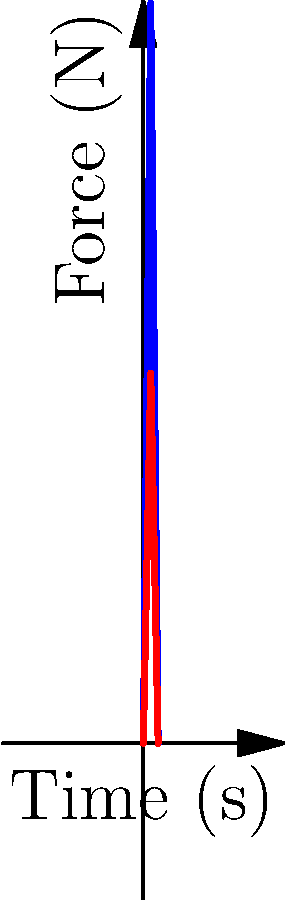The graph shows force-plate data comparing the vertical ground reaction force during a single step for a healthy control and an ankylosing spondylitis (AS) patient. What key biomechanical difference does this data suggest about the AS patient's gait, and how might this inform your therapeutic exercise approach? To analyze this force-plate data and understand its implications for an AS patient's gait, let's break it down step-by-step:

1. Curve interpretation:
   - The blue curve represents the healthy control's vertical ground reaction force.
   - The red curve represents the AS patient's vertical ground reaction force.

2. Key differences:
   - Peak force: The healthy control's peak force is approximately 150N, while the AS patient's peak is about 75N.
   - Force generation rate: The slope of the curve is steeper for the healthy control, indicating a faster rate of force development.

3. Biomechanical implications:
   - Reduced peak force: The AS patient is generating significantly less vertical force during the step, suggesting decreased weight-bearing or force production capacity.
   - Slower force development: The more gradual increase in force for the AS patient may indicate slower weight transfer or difficulty in rapid force production.

4. Potential causes in AS patients:
   - Spinal stiffness and reduced mobility
   - Pain avoidance behaviors
   - Muscle weakness, particularly in the lower extremities
   - Altered proprioception and balance issues

5. Therapeutic exercise approach:
   - Focus on improving lower extremity strength, particularly in weight-bearing positions.
   - Incorporate exercises that challenge rapid force production, such as plyometrics or quick stepping activities.
   - Include balance and proprioception training to enhance weight transfer and force control.
   - Gradually progress weight-bearing activities to improve force tolerance and production.
   - Address spinal mobility and overall posture to optimize biomechanical efficiency.

6. Monitoring progress:
   - Regularly reassess force-plate data to track improvements in peak force and rate of force development.
   - Use this data to guide exercise progression and identify areas needing continued focus.

The key biomechanical difference suggested by this data is the reduced force production capacity in the AS patient, which informs a therapeutic approach focused on improving strength, power, and weight-bearing tolerance.
Answer: Reduced force production capacity, informing focus on strength, power, and weight-bearing exercises. 